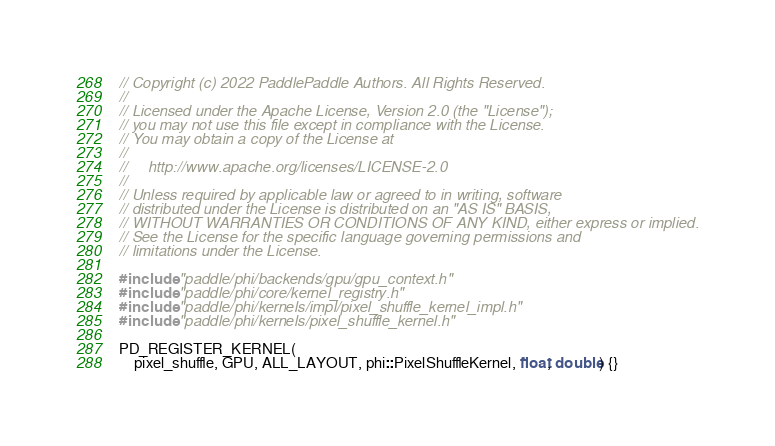Convert code to text. <code><loc_0><loc_0><loc_500><loc_500><_Cuda_>// Copyright (c) 2022 PaddlePaddle Authors. All Rights Reserved.
//
// Licensed under the Apache License, Version 2.0 (the "License");
// you may not use this file except in compliance with the License.
// You may obtain a copy of the License at
//
//     http://www.apache.org/licenses/LICENSE-2.0
//
// Unless required by applicable law or agreed to in writing, software
// distributed under the License is distributed on an "AS IS" BASIS,
// WITHOUT WARRANTIES OR CONDITIONS OF ANY KIND, either express or implied.
// See the License for the specific language governing permissions and
// limitations under the License.

#include "paddle/phi/backends/gpu/gpu_context.h"
#include "paddle/phi/core/kernel_registry.h"
#include "paddle/phi/kernels/impl/pixel_shuffle_kernel_impl.h"
#include "paddle/phi/kernels/pixel_shuffle_kernel.h"

PD_REGISTER_KERNEL(
    pixel_shuffle, GPU, ALL_LAYOUT, phi::PixelShuffleKernel, float, double) {}
</code> 